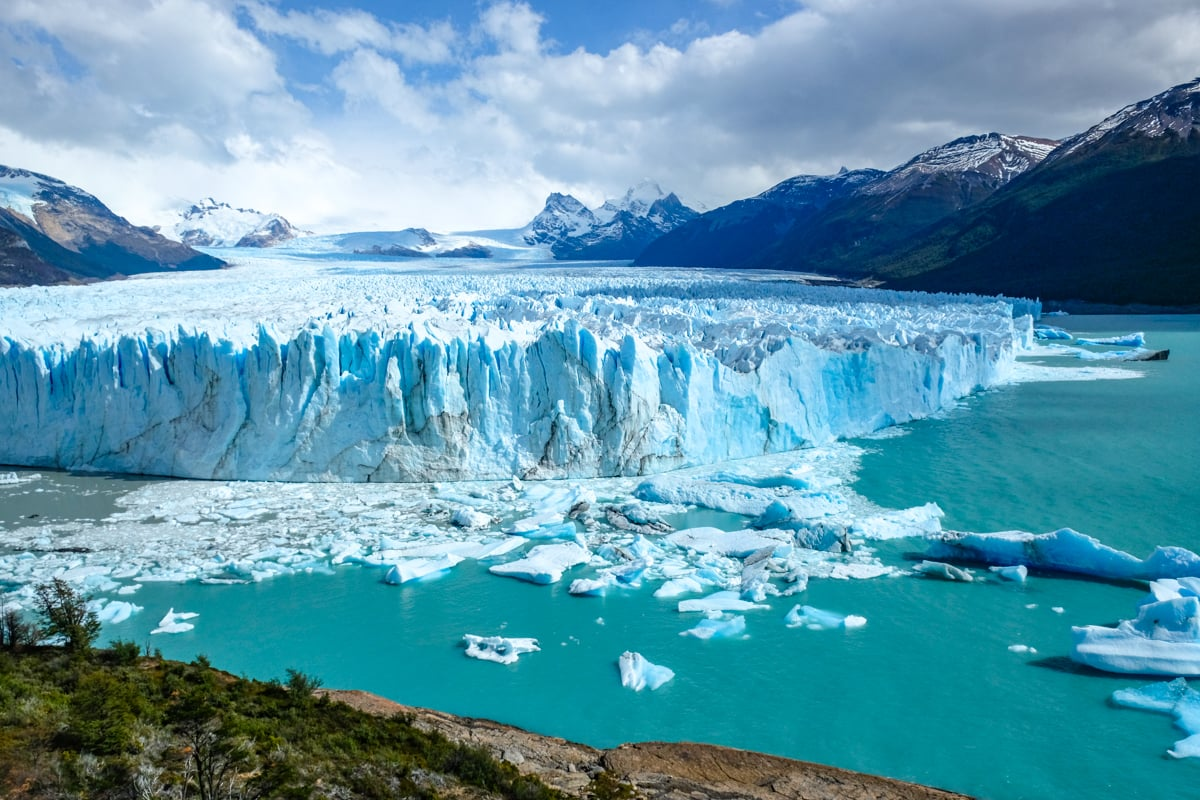Imagine if the glacier could speak. What stories might it tell about its history and the changes it has witnessed over millennia? If the glacier could speak, it might recount stories of ancient times when it was formed during the last Ice Age, slowly sculpted by the forces of nature over millennia. It would speak of the gradual yet powerful movements that carved out the surrounding landscape, the shifts in climate it has endured, and the countless seasons of freezing and thawing. The glacier could tell tales of indigenous peoples who once lived in its shadow, of explorers who first discovered its colossal beauty, and of the many tourists who now come to marvel at its grandeur. It might share its observations on the impact of climate change, witnessing the subtle yet persistent alterations to its own structure and the surrounding environment. Each crack and crevice in its surface might echo with the history of the Earth itself, bearing silent witness to the continuous ebb and flow of geological time. 